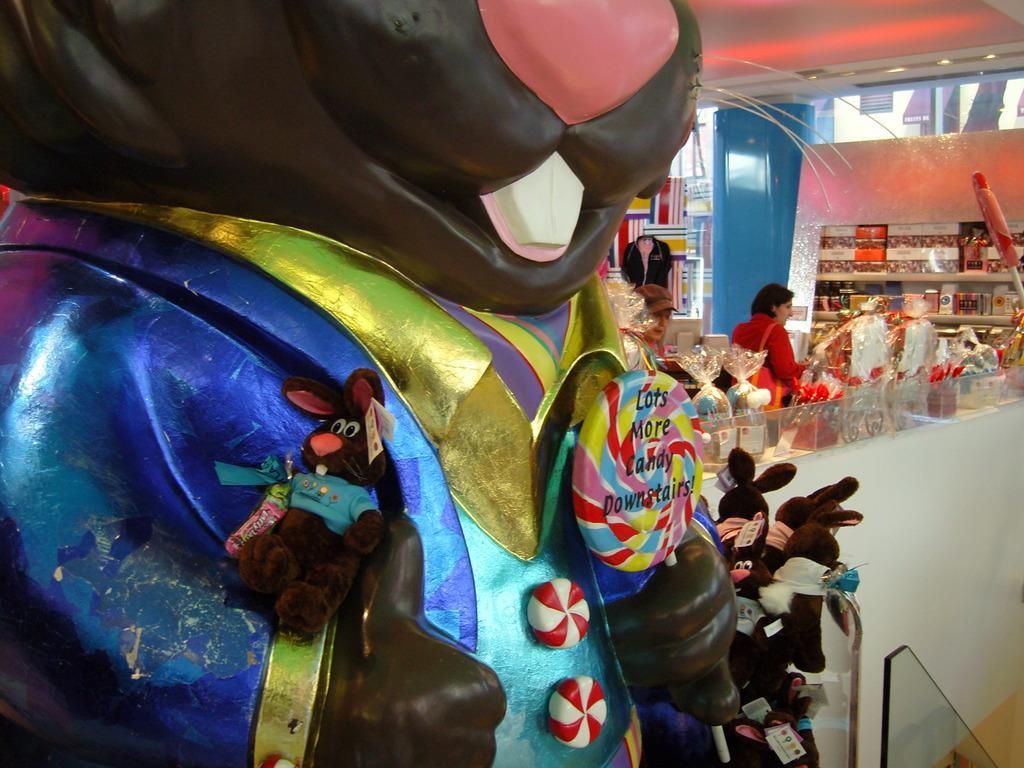Can you describe this image briefly? In this image I can see a woman is standing. Here i can see some soft toys. In the background I can see objects on the table. I can also see shelves which has some objects. Here I can see lights on the ceiling. 